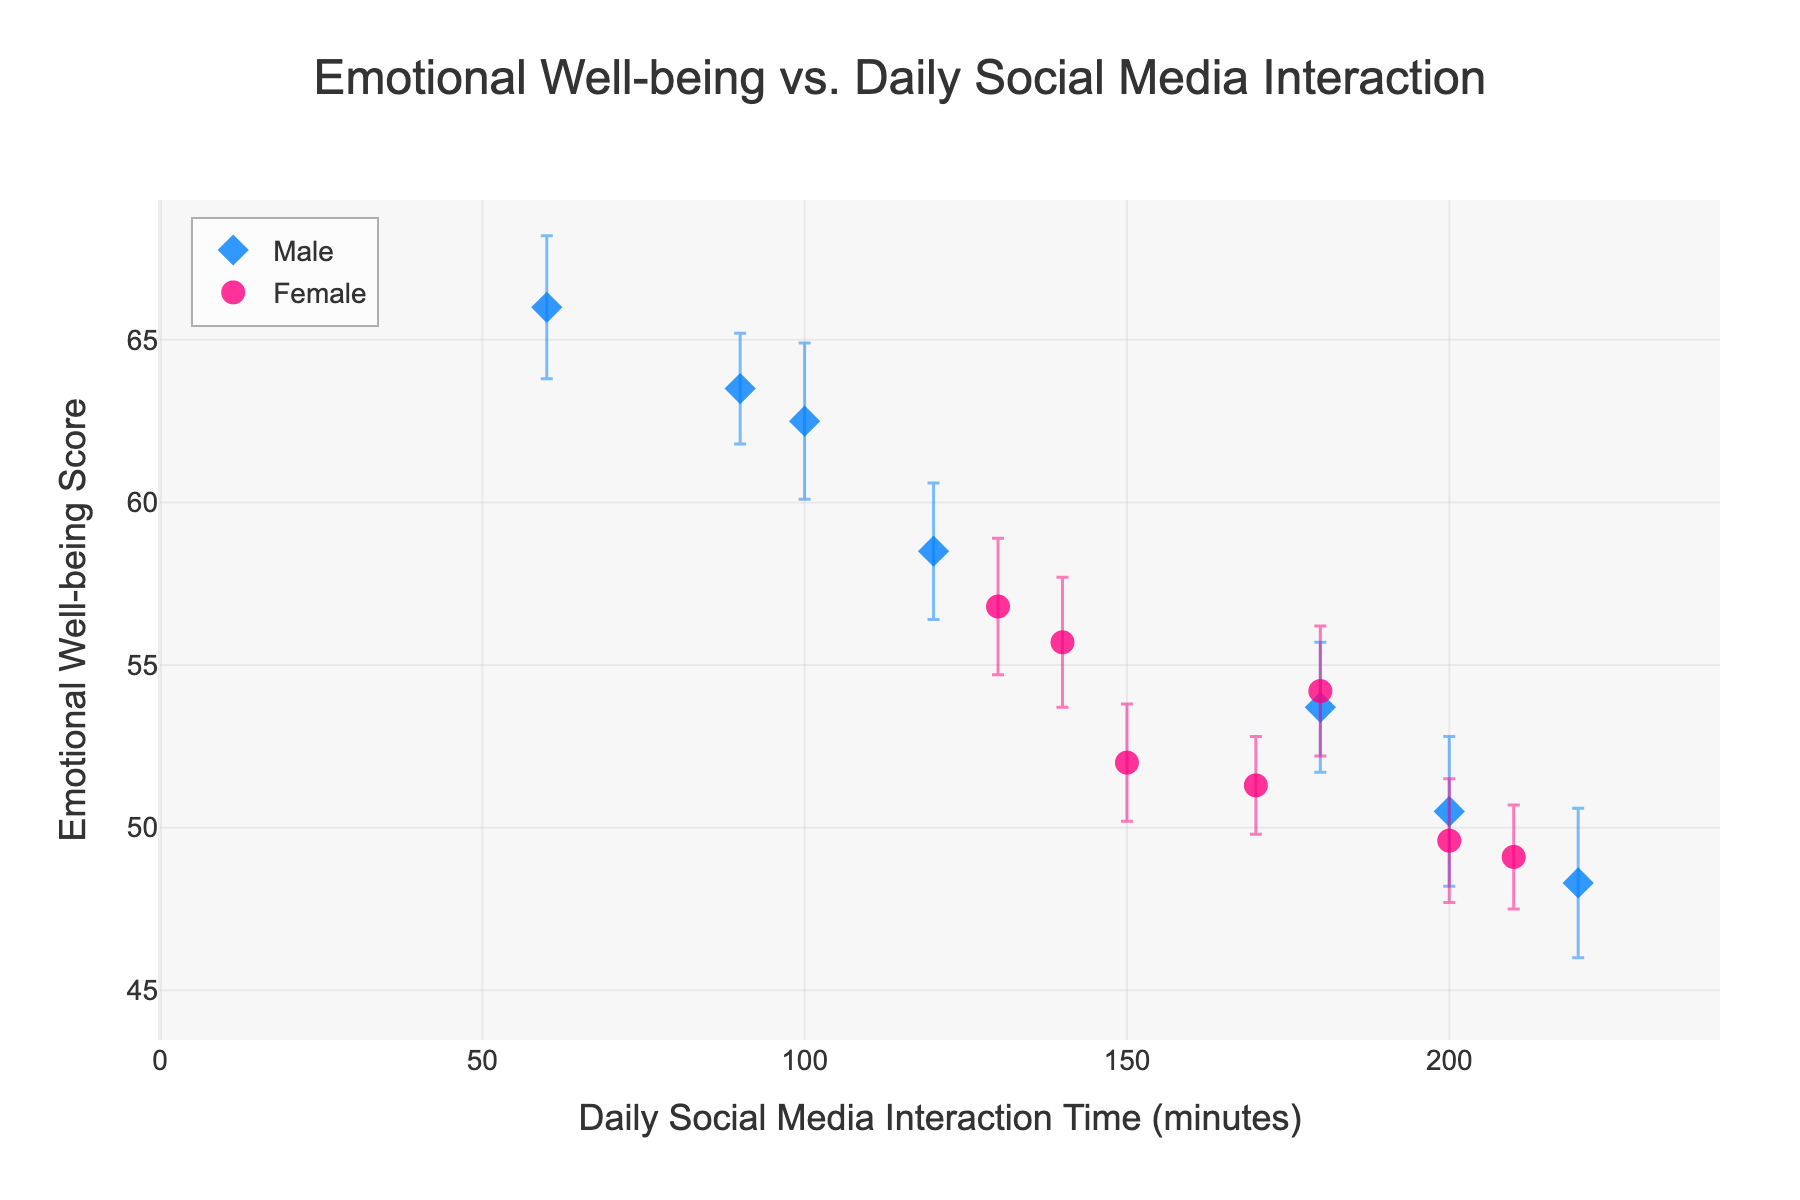What is the title of the scatter plot? The title is generally located at the top center of the figure and is included to provide context about the content in the plot.
Answer: Emotional Well-being vs. Daily Social Media Interaction What are the axis titles in the scatter plot? The x-axis reflects the variable of Daily Social Media Interaction Time (minutes), and the y-axis represents Emotional Well-being Score, as indicated by their respective labels.
Answer: Daily Social Media Interaction Time (minutes) and Emotional Well-being Score How many male data points are in the scatter plot? Male data points can be identified by their diamond shape markers; visually counting them answers the query.
Answer: 7 What is the highest Emotional Well-being Score recorded for females? By scanning the y-axis for the tallest female data point (circular marker), the highest score of females is located.
Answer: 56.8 Which adolescent has the highest daily social media interaction time? By finding the furthest point to the right on the x-axis in the plot for males and females, we identify the individual.
Answer: Michael What is the difference between the highest and lowest Emotional Well-being Score among males? Identify the highest (66.0 for William) and lowest (48.3 for Michael) y-values for male data points and subtract the latter from the former.
Answer: 17.7 Compare the Daily Social Media Interaction Time of Emily and Michael. Who spends more time, and by how much? Determine the x-values for both Emily (150) and Michael (220), then subtract Emily's time from Michael's.
Answer: Michael spends 70 minutes more Who has the smallest error margin among the female data points? Inspect the error bars for female data points and find the smallest one, which corresponds to Jessica (1.5).
Answer: Jessica Which gender generally has higher Emotional Well-being Scores based on the data points? Observing the y-values, male data points tend to be higher than female data points, indicating generally better emotional well-being.
Answer: Males How does Daily Social Media Interaction Time affect Emotional Well-being for males and females based on the scatter plot? By observing the trend in the data points, more social media time correlates with lower emotional well-being scores for both genders, inferred from points trending downwards with increasing interaction time.
Answer: Negative correlation for both genders 